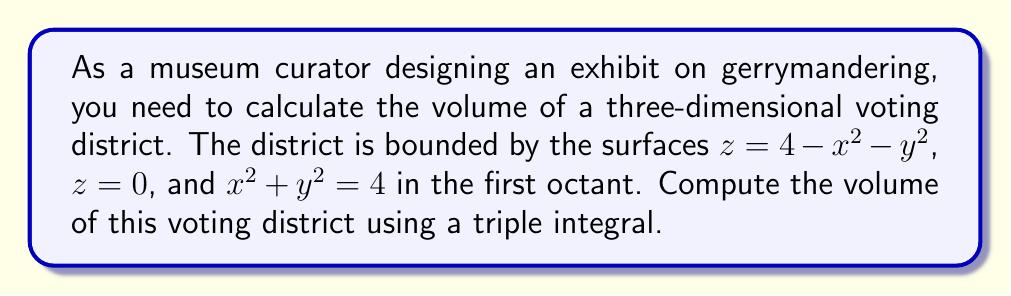Could you help me with this problem? To calculate the volume of the three-dimensional voting district, we need to set up and evaluate a triple integral. Let's approach this step-by-step:

1) The region is bounded by:
   - $z = 4 - x^2 - y^2$ (top surface)
   - $z = 0$ (bottom surface)
   - $x^2 + y^2 = 4$ (cylindrical boundary)
   - First octant (so $x \geq 0$, $y \geq 0$, $z \geq 0$)

2) We can set up the triple integral in cylindrical coordinates:
   $$ V = \int\int\int_R dV = \int_0^{\pi/2}\int_0^2\int_0^{4-r^2} r \, dz \, dr \, d\theta $$

3) Let's evaluate the integral from inside out:

   $$ V = \int_0^{\pi/2}\int_0^2 r \left[\int_0^{4-r^2} dz\right] \, dr \, d\theta $$

4) Evaluating the innermost integral:

   $$ V = \int_0^{\pi/2}\int_0^2 r \left[z\right]_0^{4-r^2} \, dr \, d\theta = \int_0^{\pi/2}\int_0^2 r(4-r^2) \, dr \, d\theta $$

5) Now, let's evaluate the integral with respect to $r$:

   $$ V = \int_0^{\pi/2} \left[\int_0^2 (4r - r^3) \, dr\right] \, d\theta = \int_0^{\pi/2} \left[2r^2 - \frac{1}{4}r^4\right]_0^2 \, d\theta $$
   $$ = \int_0^{\pi/2} (8 - 4) \, d\theta = \int_0^{\pi/2} 4 \, d\theta $$

6) Finally, evaluating the outermost integral:

   $$ V = \left[4\theta\right]_0^{\pi/2} = 4 \cdot \frac{\pi}{2} = 2\pi $$

Therefore, the volume of the voting district is $2\pi$ cubic units.
Answer: $2\pi$ cubic units 